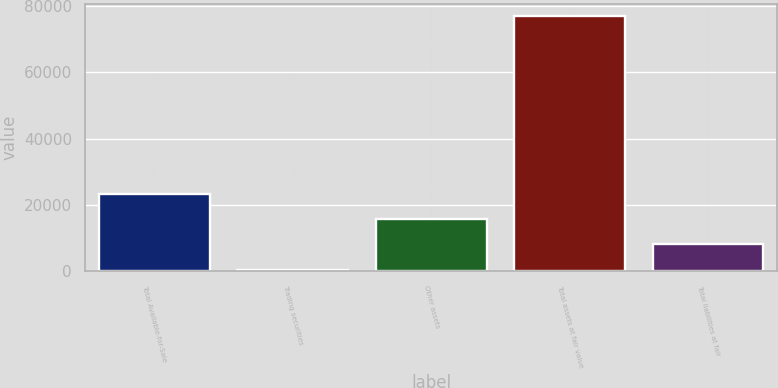Convert chart to OTSL. <chart><loc_0><loc_0><loc_500><loc_500><bar_chart><fcel>Total Available-for-Sale<fcel>Trading securities<fcel>Other assets<fcel>Total assets at fair value<fcel>Total liabilities at fair<nl><fcel>23407.5<fcel>498<fcel>15771<fcel>76863<fcel>8134.5<nl></chart> 